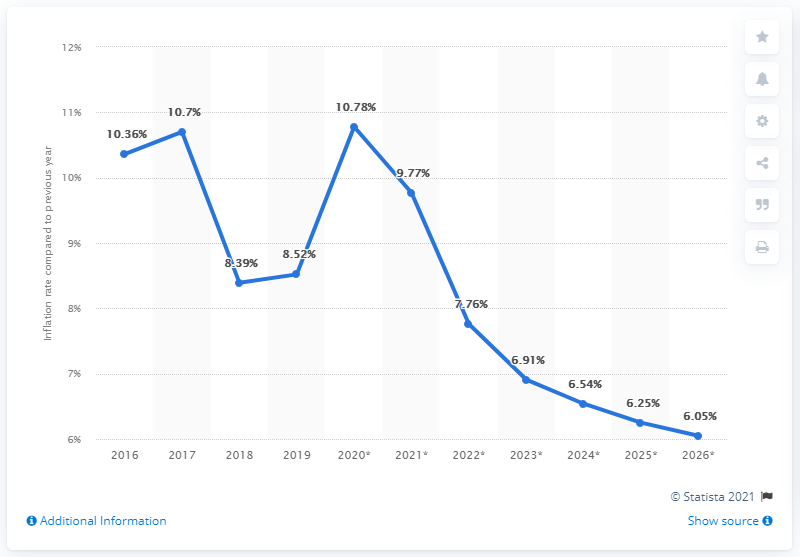Highlight a few significant elements in this photo. In 2016, the average inflation rate in Sub-Saharan Africa was X. 